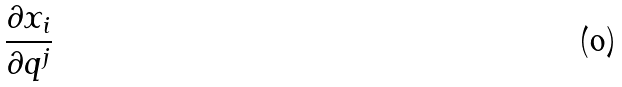Convert formula to latex. <formula><loc_0><loc_0><loc_500><loc_500>\frac { \partial x _ { i } } { \partial q ^ { j } }</formula> 